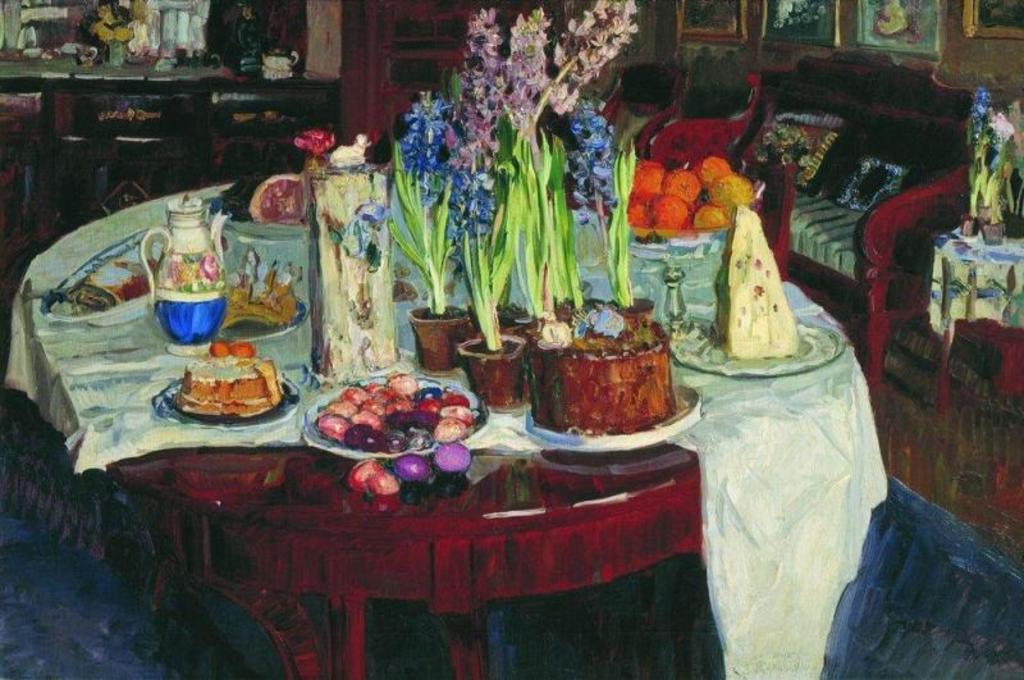Describe this image in one or two sentences. In this picture I can see a a painting of food items on the plates, flower vases and some other objects on the table, there is a couch with pillows, there are frames attached to the wall and there are some objects. 